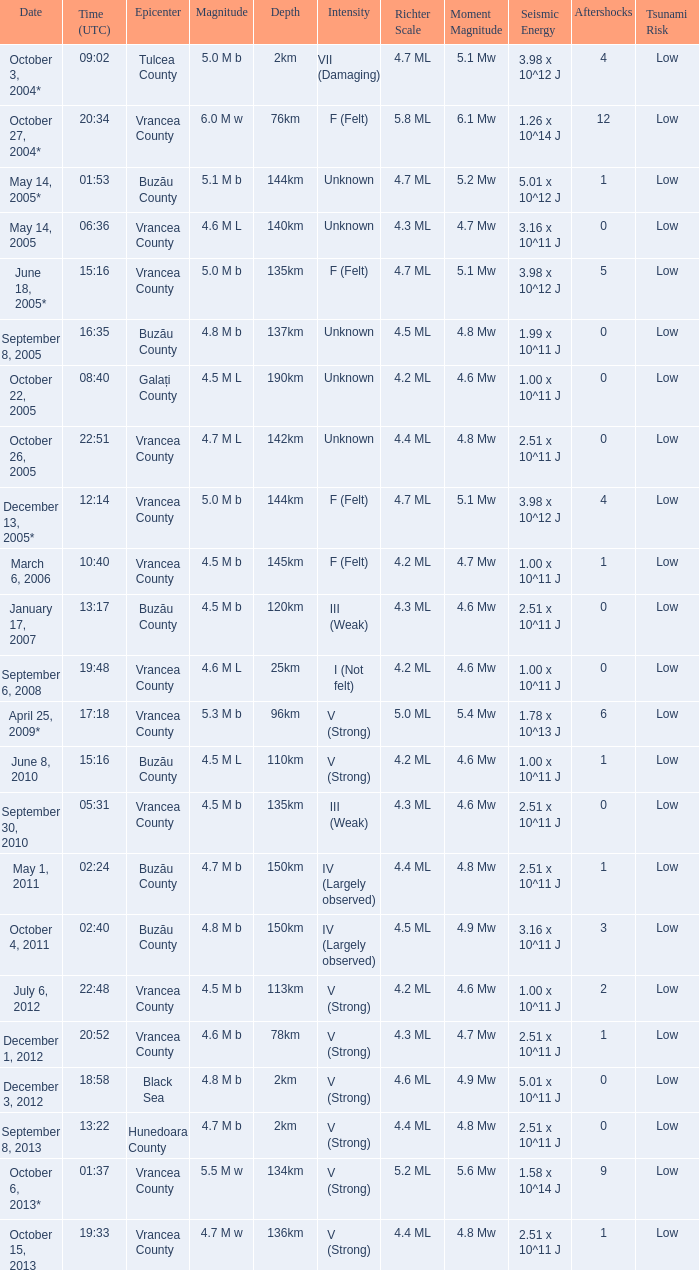I'm looking to parse the entire table for insights. Could you assist me with that? {'header': ['Date', 'Time (UTC)', 'Epicenter', 'Magnitude', 'Depth', 'Intensity', 'Richter Scale', 'Moment Magnitude', 'Seismic Energy', 'Aftershocks', 'Tsunami Risk'], 'rows': [['October 3, 2004*', '09:02', 'Tulcea County', '5.0 M b', '2km', 'VII (Damaging)', '4.7 ML', '5.1 Mw', '3.98 x 10^12 J', '4', 'Low'], ['October 27, 2004*', '20:34', 'Vrancea County', '6.0 M w', '76km', 'F (Felt)', '5.8 ML', '6.1 Mw', '1.26 x 10^14 J', '12', 'Low'], ['May 14, 2005*', '01:53', 'Buzău County', '5.1 M b', '144km', 'Unknown', '4.7 ML', '5.2 Mw', '5.01 x 10^12 J', '1', 'Low'], ['May 14, 2005', '06:36', 'Vrancea County', '4.6 M L', '140km', 'Unknown', '4.3 ML', '4.7 Mw', '3.16 x 10^11 J', '0', 'Low'], ['June 18, 2005*', '15:16', 'Vrancea County', '5.0 M b', '135km', 'F (Felt)', '4.7 ML', '5.1 Mw', '3.98 x 10^12 J', '5', 'Low'], ['September 8, 2005', '16:35', 'Buzău County', '4.8 M b', '137km', 'Unknown', '4.5 ML', '4.8 Mw', '1.99 x 10^11 J', '0', 'Low'], ['October 22, 2005', '08:40', 'Galați County', '4.5 M L', '190km', 'Unknown', '4.2 ML', '4.6 Mw', '1.00 x 10^11 J', '0', 'Low'], ['October 26, 2005', '22:51', 'Vrancea County', '4.7 M L', '142km', 'Unknown', '4.4 ML', '4.8 Mw', '2.51 x 10^11 J', '0', 'Low'], ['December 13, 2005*', '12:14', 'Vrancea County', '5.0 M b', '144km', 'F (Felt)', '4.7 ML', '5.1 Mw', '3.98 x 10^12 J', '4', 'Low'], ['March 6, 2006', '10:40', 'Vrancea County', '4.5 M b', '145km', 'F (Felt)', '4.2 ML', '4.7 Mw', '1.00 x 10^11 J', '1', 'Low'], ['January 17, 2007', '13:17', 'Buzău County', '4.5 M b', '120km', 'III (Weak)', '4.3 ML', '4.6 Mw', '2.51 x 10^11 J', '0', 'Low'], ['September 6, 2008', '19:48', 'Vrancea County', '4.6 M L', '25km', 'I (Not felt)', '4.2 ML', '4.6 Mw', '1.00 x 10^11 J', '0', 'Low'], ['April 25, 2009*', '17:18', 'Vrancea County', '5.3 M b', '96km', 'V (Strong)', '5.0 ML', '5.4 Mw', '1.78 x 10^13 J', '6', 'Low'], ['June 8, 2010', '15:16', 'Buzău County', '4.5 M L', '110km', 'V (Strong)', '4.2 ML', '4.6 Mw', '1.00 x 10^11 J', '1', 'Low'], ['September 30, 2010', '05:31', 'Vrancea County', '4.5 M b', '135km', 'III (Weak)', '4.3 ML', '4.6 Mw', '2.51 x 10^11 J', '0', 'Low'], ['May 1, 2011', '02:24', 'Buzău County', '4.7 M b', '150km', 'IV (Largely observed)', '4.4 ML', '4.8 Mw', '2.51 x 10^11 J', '1', 'Low'], ['October 4, 2011', '02:40', 'Buzău County', '4.8 M b', '150km', 'IV (Largely observed)', '4.5 ML', '4.9 Mw', '3.16 x 10^11 J', '3', 'Low'], ['July 6, 2012', '22:48', 'Vrancea County', '4.5 M b', '113km', 'V (Strong)', '4.2 ML', '4.6 Mw', '1.00 x 10^11 J', '2', 'Low'], ['December 1, 2012', '20:52', 'Vrancea County', '4.6 M b', '78km', 'V (Strong)', '4.3 ML', '4.7 Mw', '2.51 x 10^11 J', '1', 'Low'], ['December 3, 2012', '18:58', 'Black Sea', '4.8 M b', '2km', 'V (Strong)', '4.6 ML', '4.9 Mw', '5.01 x 10^11 J', '0', 'Low'], ['September 8, 2013', '13:22', 'Hunedoara County', '4.7 M b', '2km', 'V (Strong)', '4.4 ML', '4.8 Mw', '2.51 x 10^11 J', '0', 'Low'], ['October 6, 2013*', '01:37', 'Vrancea County', '5.5 M w', '134km', 'V (Strong)', '5.2 ML', '5.6 Mw', '1.58 x 10^14 J', '9', 'Low'], ['October 15, 2013', '19:33', 'Vrancea County', '4.7 M w', '136km', 'V (Strong)', '4.4 ML', '4.8 Mw', '2.51 x 10^11 J', '1', 'Low']]} Where was the epicenter of the quake on December 1, 2012? Vrancea County. 